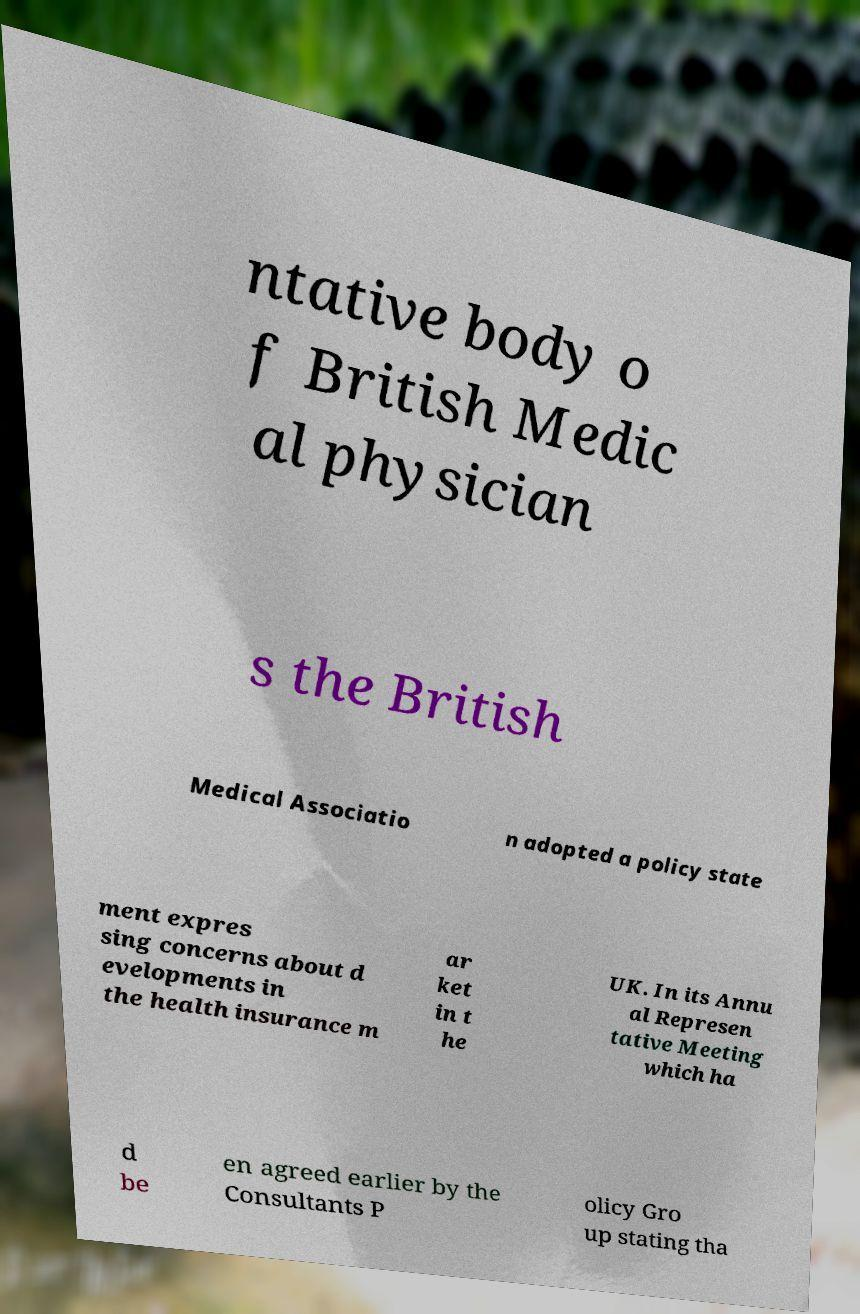What messages or text are displayed in this image? I need them in a readable, typed format. ntative body o f British Medic al physician s the British Medical Associatio n adopted a policy state ment expres sing concerns about d evelopments in the health insurance m ar ket in t he UK. In its Annu al Represen tative Meeting which ha d be en agreed earlier by the Consultants P olicy Gro up stating tha 